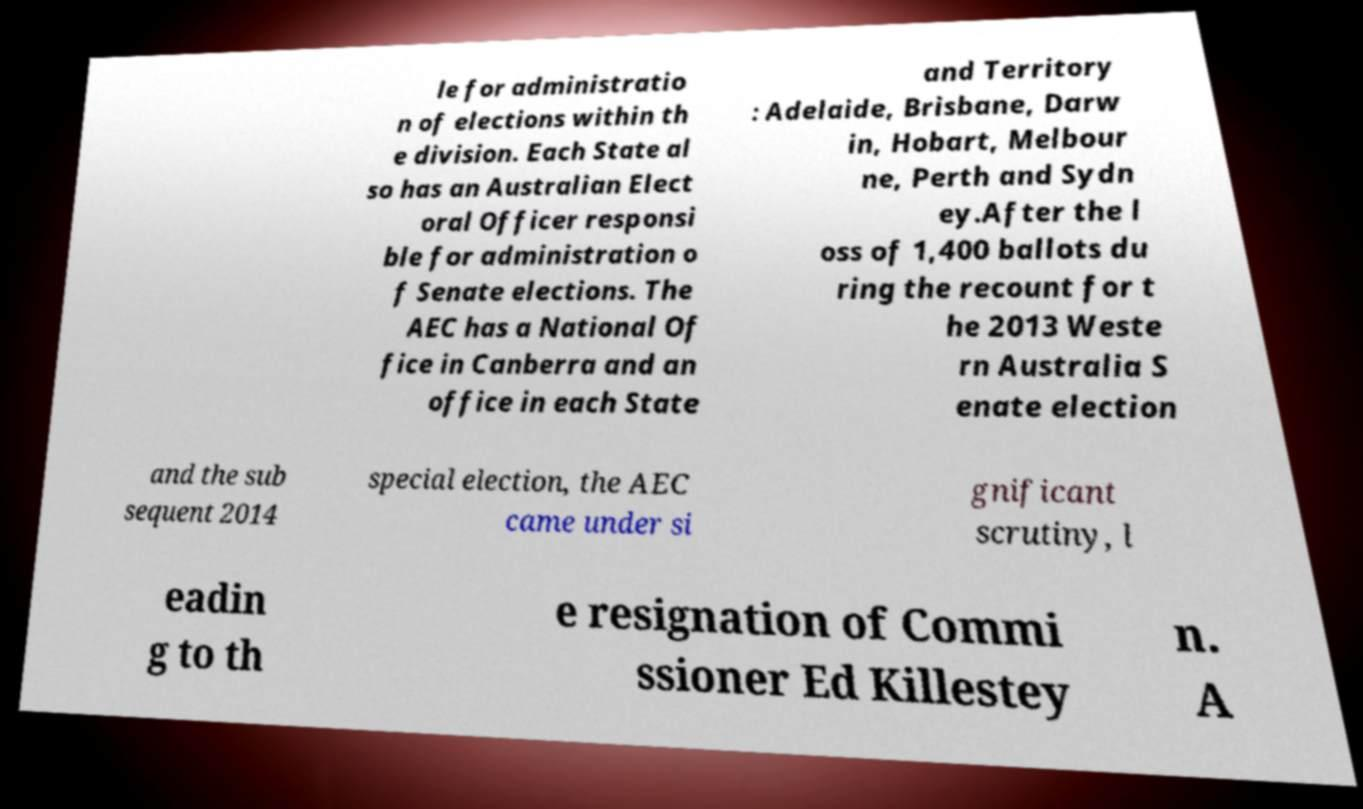Can you accurately transcribe the text from the provided image for me? le for administratio n of elections within th e division. Each State al so has an Australian Elect oral Officer responsi ble for administration o f Senate elections. The AEC has a National Of fice in Canberra and an office in each State and Territory : Adelaide, Brisbane, Darw in, Hobart, Melbour ne, Perth and Sydn ey.After the l oss of 1,400 ballots du ring the recount for t he 2013 Weste rn Australia S enate election and the sub sequent 2014 special election, the AEC came under si gnificant scrutiny, l eadin g to th e resignation of Commi ssioner Ed Killestey n. A 